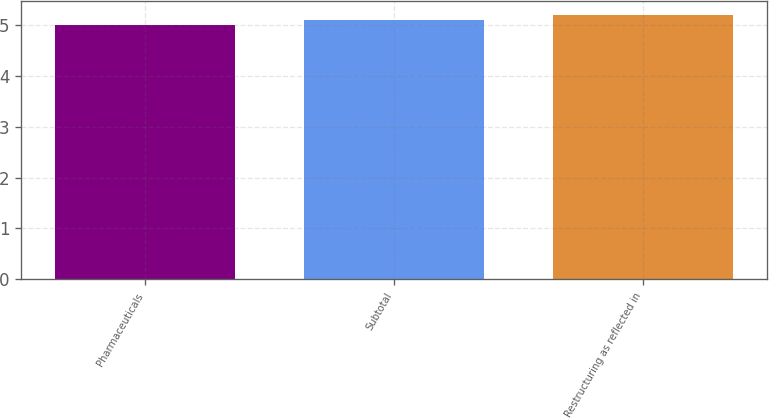Convert chart. <chart><loc_0><loc_0><loc_500><loc_500><bar_chart><fcel>Pharmaceuticals<fcel>Subtotal<fcel>Restructuring as reflected in<nl><fcel>5<fcel>5.1<fcel>5.2<nl></chart> 